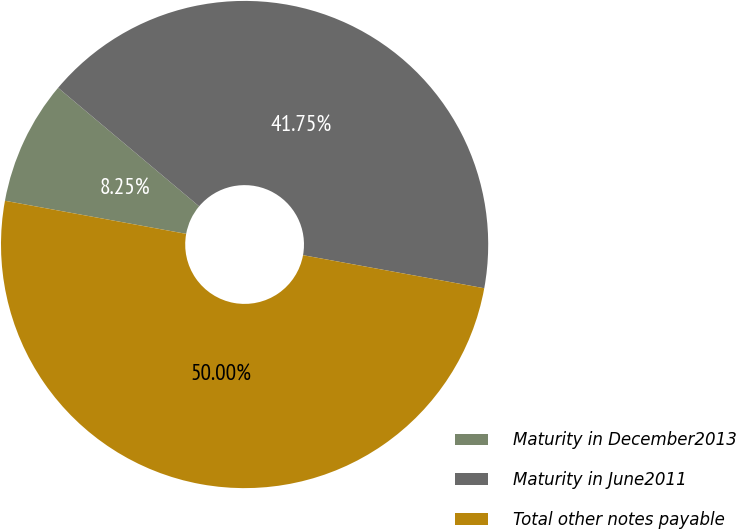<chart> <loc_0><loc_0><loc_500><loc_500><pie_chart><fcel>Maturity in December2013<fcel>Maturity in June2011<fcel>Total other notes payable<nl><fcel>8.25%<fcel>41.75%<fcel>50.0%<nl></chart> 